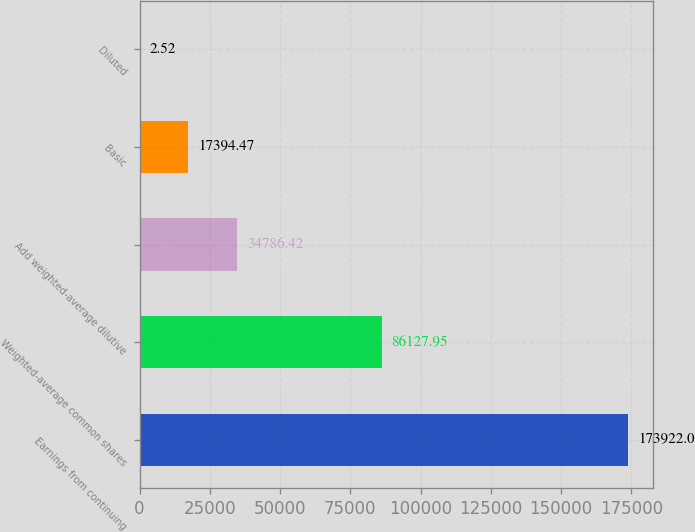<chart> <loc_0><loc_0><loc_500><loc_500><bar_chart><fcel>Earnings from continuing<fcel>Weighted-average common shares<fcel>Add weighted-average dilutive<fcel>Basic<fcel>Diluted<nl><fcel>173922<fcel>86127.9<fcel>34786.4<fcel>17394.5<fcel>2.52<nl></chart> 